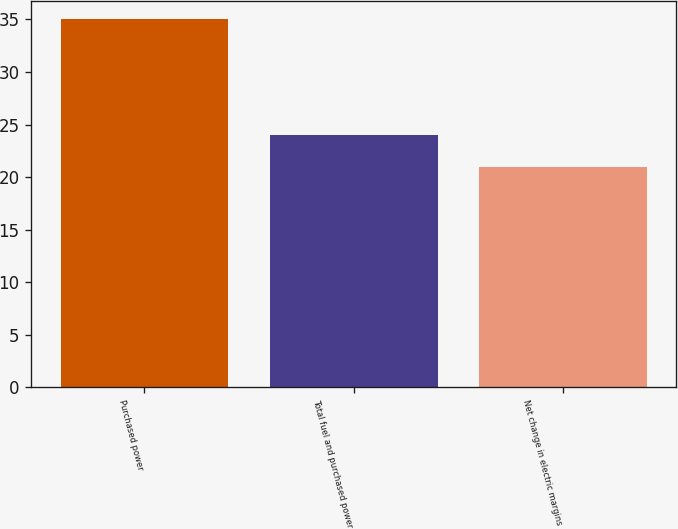<chart> <loc_0><loc_0><loc_500><loc_500><bar_chart><fcel>Purchased power<fcel>Total fuel and purchased power<fcel>Net change in electric margins<nl><fcel>35<fcel>24<fcel>21<nl></chart> 